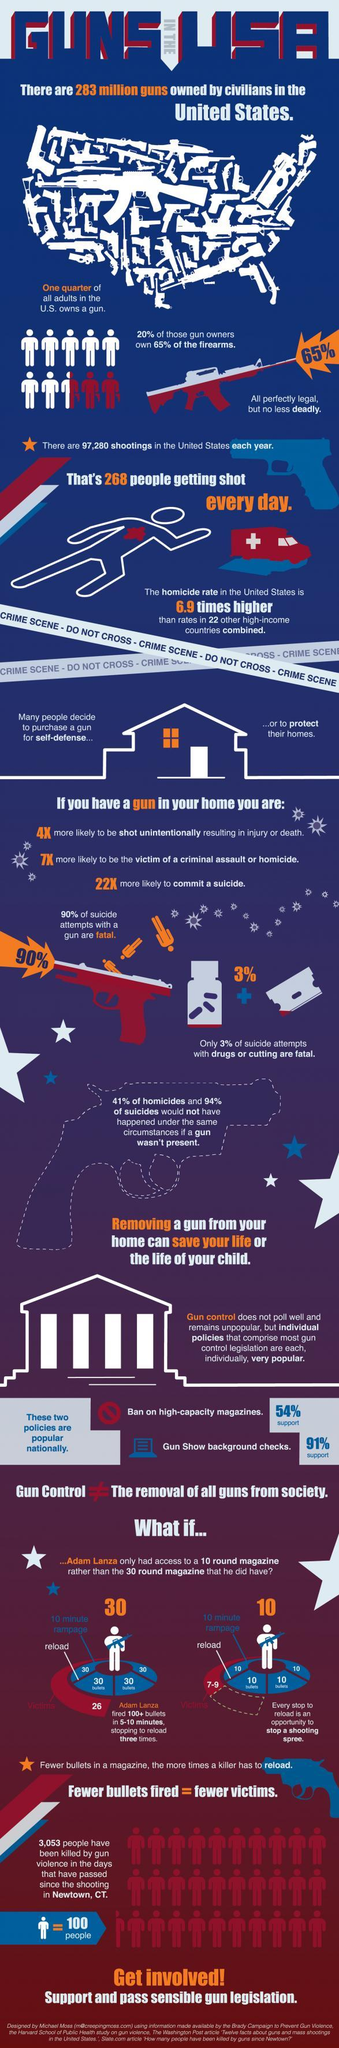What are the number of gun shootings in the US per annum?
Answer the question with a short phrase. 97,280 If you possess a gun, "how many times more"  are your chances of being a victim of assault? 4 If Adam Lanza had used a 10 round magazine, how many victims would have been there? 7-9 What are the two reasons why people purchase guns in the US? Self-defense, protect their homes Which is more fatal, suicide using drugs or suicide using guns? Suicide using guns Which is the most popular of the two policies for gun control? Gun show background checks What percentage of adults in the US own a gun? 25% How many times did Adam Lanza  reload his gun? Three What magazine did Adam Lanza use? 30 round magazine What is the number of shootings per day in the US? 268 If you possess a gun, 'how many times higher' are your chances of committing suicide, than otherwise? 22 Which are the two popular gun control policies? Ban on high-capacity magazines, gun show background checks How many were victims of Adam Lanza's shooting? 26 